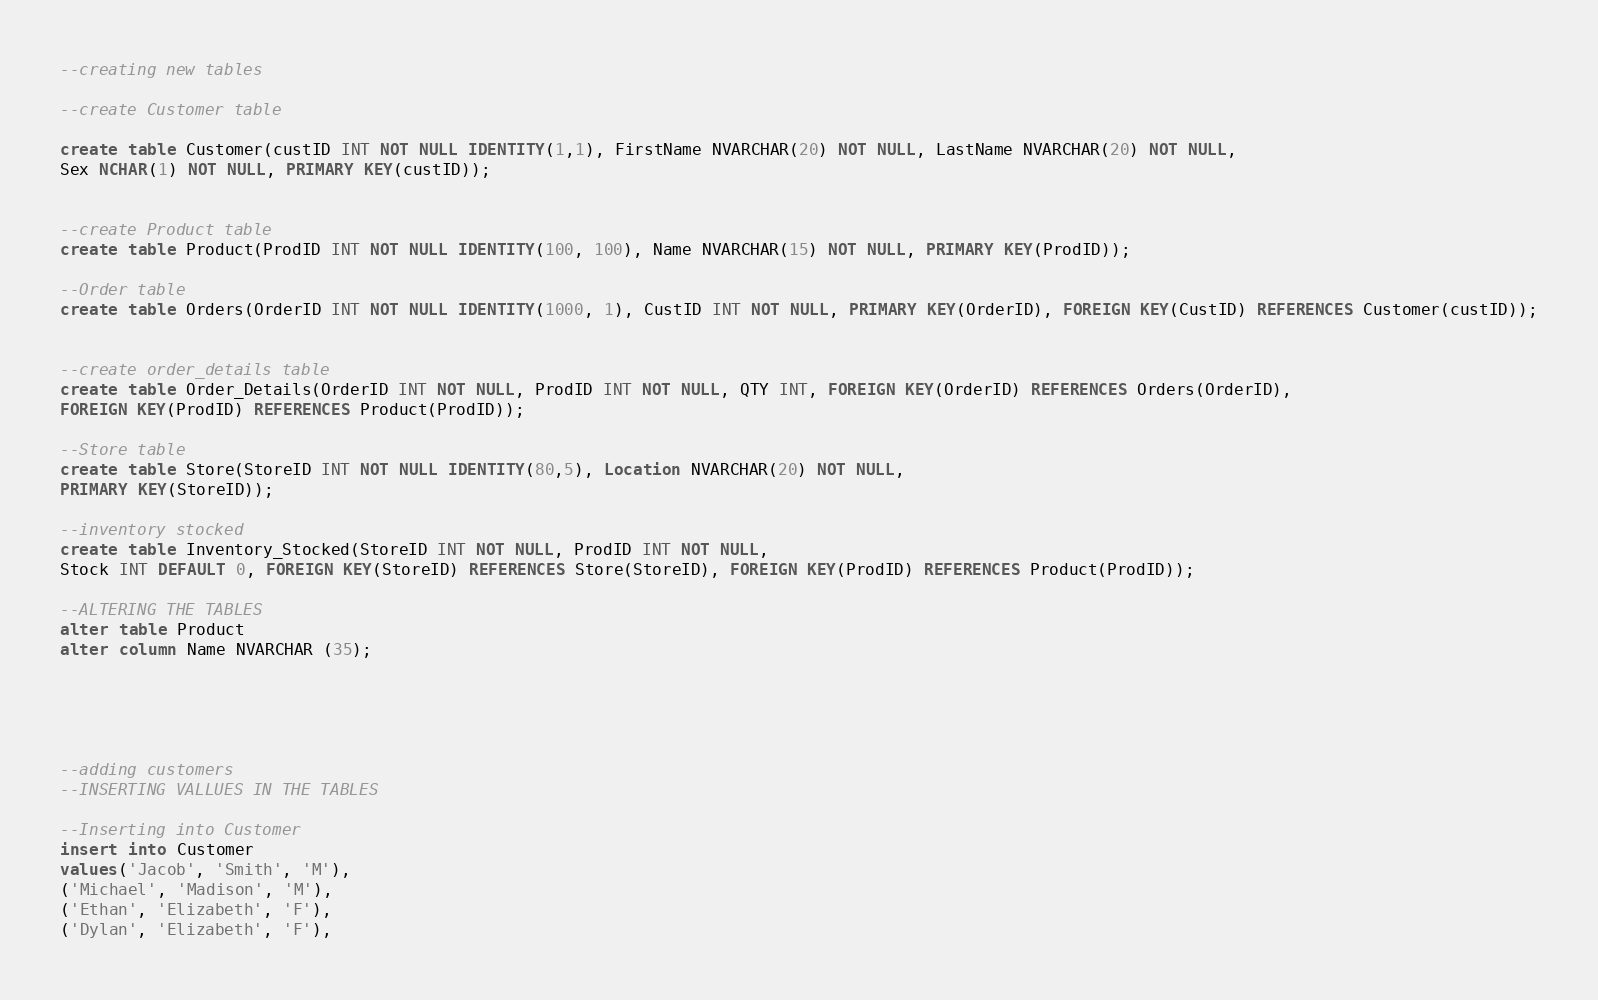<code> <loc_0><loc_0><loc_500><loc_500><_SQL_>--creating new tables

--create Customer table

create table Customer(custID INT NOT NULL IDENTITY(1,1), FirstName NVARCHAR(20) NOT NULL, LastName NVARCHAR(20) NOT NULL,
Sex NCHAR(1) NOT NULL, PRIMARY KEY(custID));


--create Product table
create table Product(ProdID INT NOT NULL IDENTITY(100, 100), Name NVARCHAR(15) NOT NULL, PRIMARY KEY(ProdID));

--Order table
create table Orders(OrderID INT NOT NULL IDENTITY(1000, 1), CustID INT NOT NULL, PRIMARY KEY(OrderID), FOREIGN KEY(CustID) REFERENCES Customer(custID));


--create order_details table
create table Order_Details(OrderID INT NOT NULL, ProdID INT NOT NULL, QTY INT, FOREIGN KEY(OrderID) REFERENCES Orders(OrderID),
FOREIGN KEY(ProdID) REFERENCES Product(ProdID));

--Store table
create table Store(StoreID INT NOT NULL IDENTITY(80,5), Location NVARCHAR(20) NOT NULL,
PRIMARY KEY(StoreID));

--inventory stocked
create table Inventory_Stocked(StoreID INT NOT NULL, ProdID INT NOT NULL,
Stock INT DEFAULT 0, FOREIGN KEY(StoreID) REFERENCES Store(StoreID), FOREIGN KEY(ProdID) REFERENCES Product(ProdID));

--ALTERING THE TABLES
alter table Product
alter column Name NVARCHAR (35);





--adding customers
--INSERTING VALLUES IN THE TABLES

--Inserting into Customer
insert into Customer
values('Jacob', 'Smith', 'M'),
('Michael', 'Madison', 'M'),
('Ethan', 'Elizabeth', 'F'),
('Dylan', 'Elizabeth', 'F'),</code> 